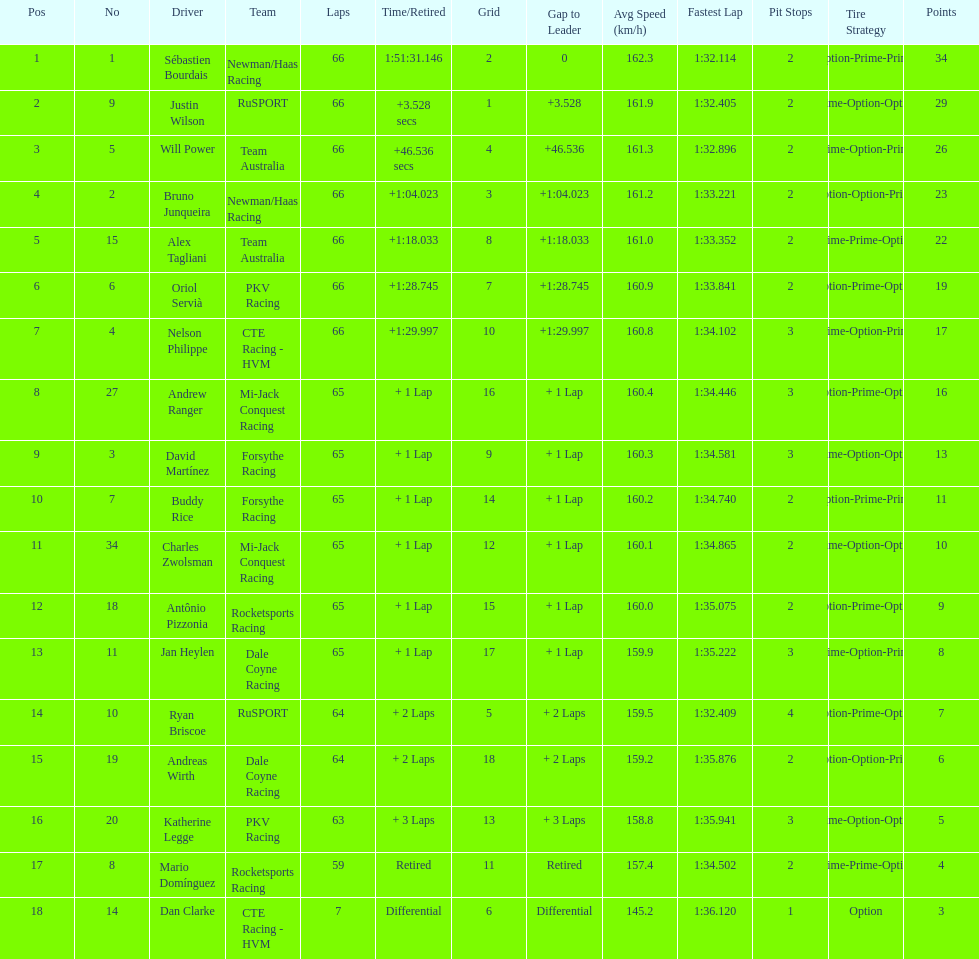Parse the full table. {'header': ['Pos', 'No', 'Driver', 'Team', 'Laps', 'Time/Retired', 'Grid', 'Gap to Leader', 'Avg Speed (km/h)', 'Fastest Lap', 'Pit Stops', 'Tire Strategy', 'Points'], 'rows': [['1', '1', 'Sébastien Bourdais', 'Newman/Haas Racing', '66', '1:51:31.146', '2', '0', '162.3', '1:32.114', '2', 'Option-Prime-Prime', '34'], ['2', '9', 'Justin Wilson', 'RuSPORT', '66', '+3.528 secs', '1', '+3.528', '161.9', '1:32.405', '2', 'Prime-Option-Option', '29'], ['3', '5', 'Will Power', 'Team Australia', '66', '+46.536 secs', '4', '+46.536', '161.3', '1:32.896', '2', 'Prime-Option-Prime', '26'], ['4', '2', 'Bruno Junqueira', 'Newman/Haas Racing', '66', '+1:04.023', '3', '+1:04.023', '161.2', '1:33.221', '2', 'Option-Option-Prime', '23'], ['5', '15', 'Alex Tagliani', 'Team Australia', '66', '+1:18.033', '8', '+1:18.033', '161.0', '1:33.352', '2', 'Prime-Prime-Option', '22'], ['6', '6', 'Oriol Servià', 'PKV Racing', '66', '+1:28.745', '7', '+1:28.745', '160.9', '1:33.841', '2', 'Option-Prime-Option', '19'], ['7', '4', 'Nelson Philippe', 'CTE Racing - HVM', '66', '+1:29.997', '10', '+1:29.997', '160.8', '1:34.102', '3', 'Prime-Option-Prime', '17'], ['8', '27', 'Andrew Ranger', 'Mi-Jack Conquest Racing', '65', '+ 1 Lap', '16', '+ 1 Lap', '160.4', '1:34.446', '3', 'Option-Prime-Option', '16'], ['9', '3', 'David Martínez', 'Forsythe Racing', '65', '+ 1 Lap', '9', '+ 1 Lap', '160.3', '1:34.581', '3', 'Prime-Option-Option', '13'], ['10', '7', 'Buddy Rice', 'Forsythe Racing', '65', '+ 1 Lap', '14', '+ 1 Lap', '160.2', '1:34.740', '2', 'Option-Prime-Prime', '11'], ['11', '34', 'Charles Zwolsman', 'Mi-Jack Conquest Racing', '65', '+ 1 Lap', '12', '+ 1 Lap', '160.1', '1:34.865', '2', 'Prime-Option-Option', '10'], ['12', '18', 'Antônio Pizzonia', 'Rocketsports Racing', '65', '+ 1 Lap', '15', '+ 1 Lap', '160.0', '1:35.075', '2', 'Option-Prime-Option', '9'], ['13', '11', 'Jan Heylen', 'Dale Coyne Racing', '65', '+ 1 Lap', '17', '+ 1 Lap', '159.9', '1:35.222', '3', 'Prime-Option-Prime', '8'], ['14', '10', 'Ryan Briscoe', 'RuSPORT', '64', '+ 2 Laps', '5', '+ 2 Laps', '159.5', '1:32.409', '4', 'Option-Prime-Option', '7'], ['15', '19', 'Andreas Wirth', 'Dale Coyne Racing', '64', '+ 2 Laps', '18', '+ 2 Laps', '159.2', '1:35.876', '2', 'Option-Option-Prime', '6'], ['16', '20', 'Katherine Legge', 'PKV Racing', '63', '+ 3 Laps', '13', '+ 3 Laps', '158.8', '1:35.941', '3', 'Prime-Option-Option', '5'], ['17', '8', 'Mario Domínguez', 'Rocketsports Racing', '59', 'Retired', '11', 'Retired', '157.4', '1:34.502', '2', 'Prime-Prime-Option', '4'], ['18', '14', 'Dan Clarke', 'CTE Racing - HVM', '7', 'Differential', '6', 'Differential', '145.2', '1:36.120', '1', 'Option', '3']]} At the 2006 gran premio telmex, how many drivers completed less than 60 laps? 2. 